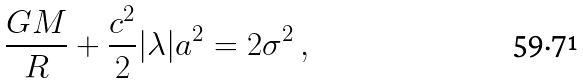<formula> <loc_0><loc_0><loc_500><loc_500>\frac { G M } { R } + \frac { c ^ { 2 } } { 2 } | \lambda | a ^ { 2 } = 2 \sigma ^ { 2 } \ ,</formula> 